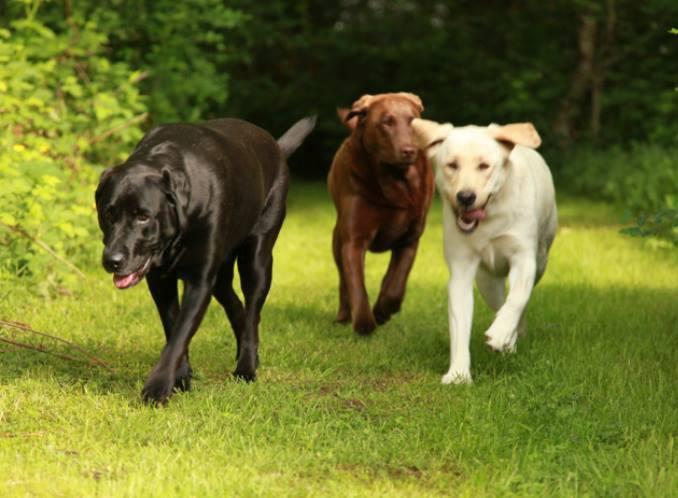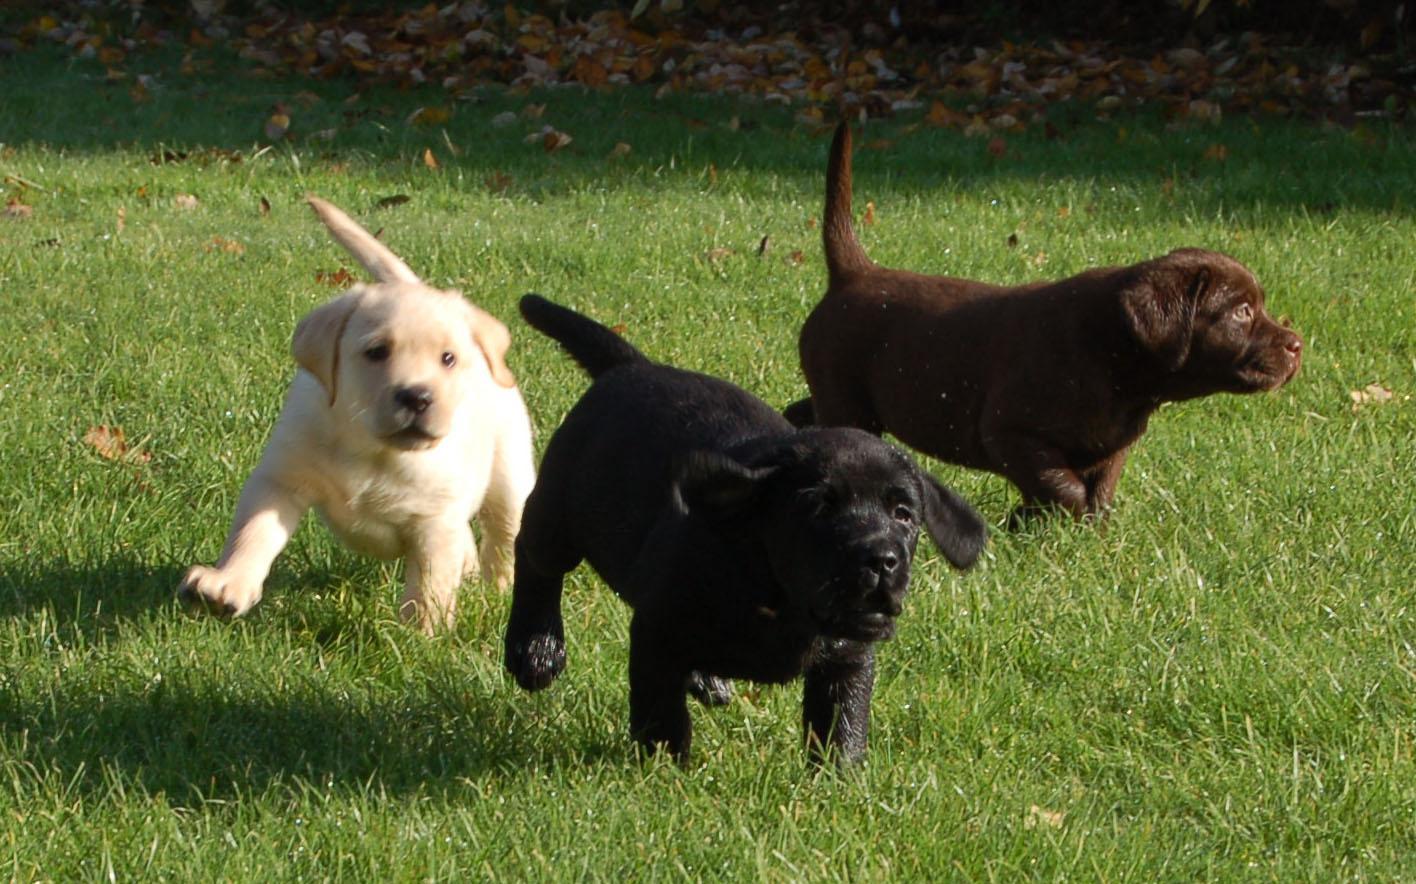The first image is the image on the left, the second image is the image on the right. Evaluate the accuracy of this statement regarding the images: "One of the dogs is missing a front leg.". Is it true? Answer yes or no. No. The first image is the image on the left, the second image is the image on the right. Analyze the images presented: Is the assertion "One image features one dog that is missing a front limb, and the other image contains at least twice as many dogs." valid? Answer yes or no. No. 